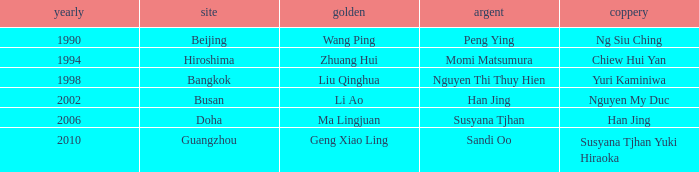Can you give me this table as a dict? {'header': ['yearly', 'site', 'golden', 'argent', 'coppery'], 'rows': [['1990', 'Beijing', 'Wang Ping', 'Peng Ying', 'Ng Siu Ching'], ['1994', 'Hiroshima', 'Zhuang Hui', 'Momi Matsumura', 'Chiew Hui Yan'], ['1998', 'Bangkok', 'Liu Qinghua', 'Nguyen Thi Thuy Hien', 'Yuri Kaminiwa'], ['2002', 'Busan', 'Li Ao', 'Han Jing', 'Nguyen My Duc'], ['2006', 'Doha', 'Ma Lingjuan', 'Susyana Tjhan', 'Han Jing'], ['2010', 'Guangzhou', 'Geng Xiao Ling', 'Sandi Oo', 'Susyana Tjhan Yuki Hiraoka']]} What's the lowest Year with the Location of Bangkok? 1998.0. 